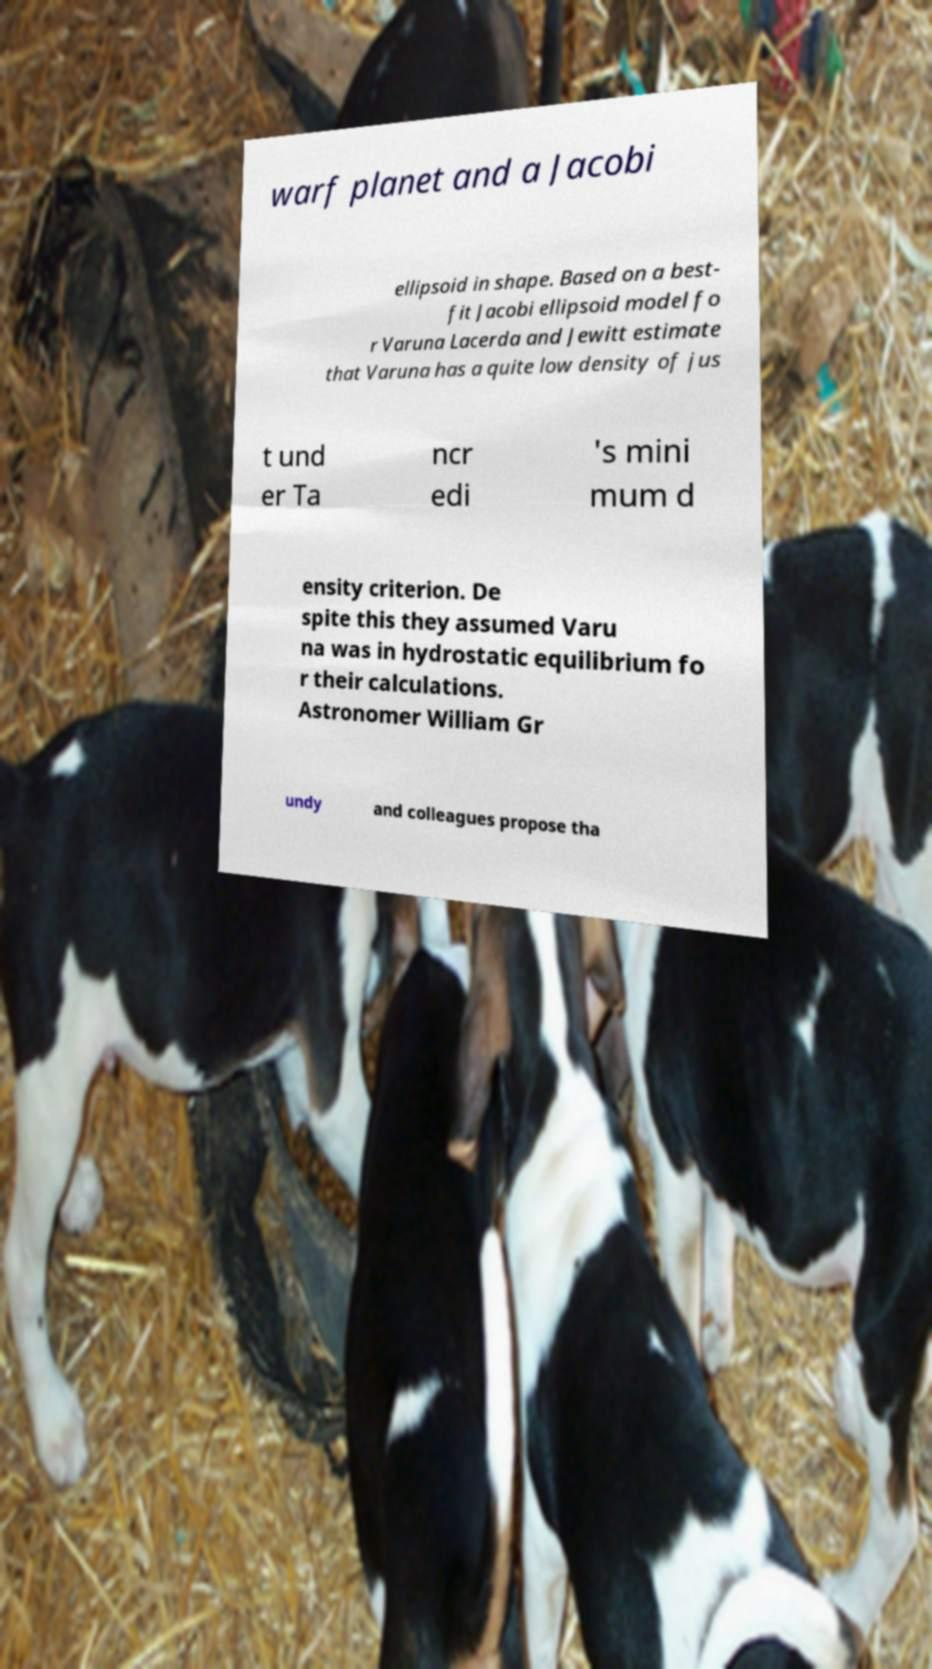I need the written content from this picture converted into text. Can you do that? warf planet and a Jacobi ellipsoid in shape. Based on a best- fit Jacobi ellipsoid model fo r Varuna Lacerda and Jewitt estimate that Varuna has a quite low density of jus t und er Ta ncr edi 's mini mum d ensity criterion. De spite this they assumed Varu na was in hydrostatic equilibrium fo r their calculations. Astronomer William Gr undy and colleagues propose tha 